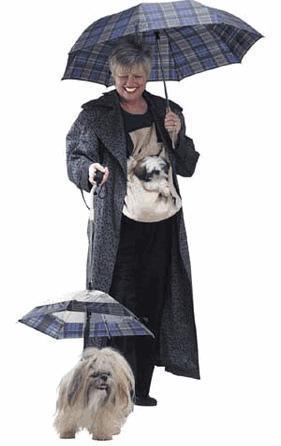How many people are shown?
Give a very brief answer. 1. How many umbrellas are shown?
Give a very brief answer. 2. How many umbrellas are there in the image?
Give a very brief answer. 2. How many dogs are in the image?
Give a very brief answer. 2. How many umbrellas can be seen?
Give a very brief answer. 2. How many skateboards are tipped up?
Give a very brief answer. 0. 